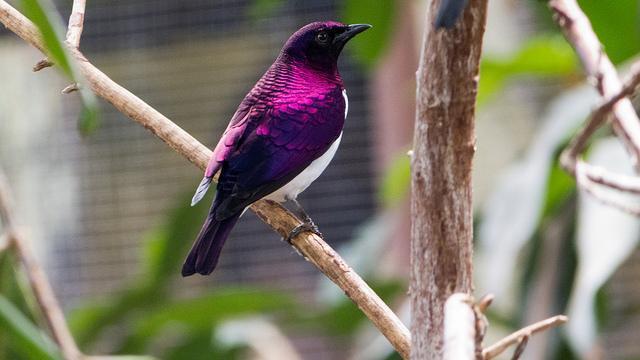How many people are wearing sandals?
Give a very brief answer. 0. 